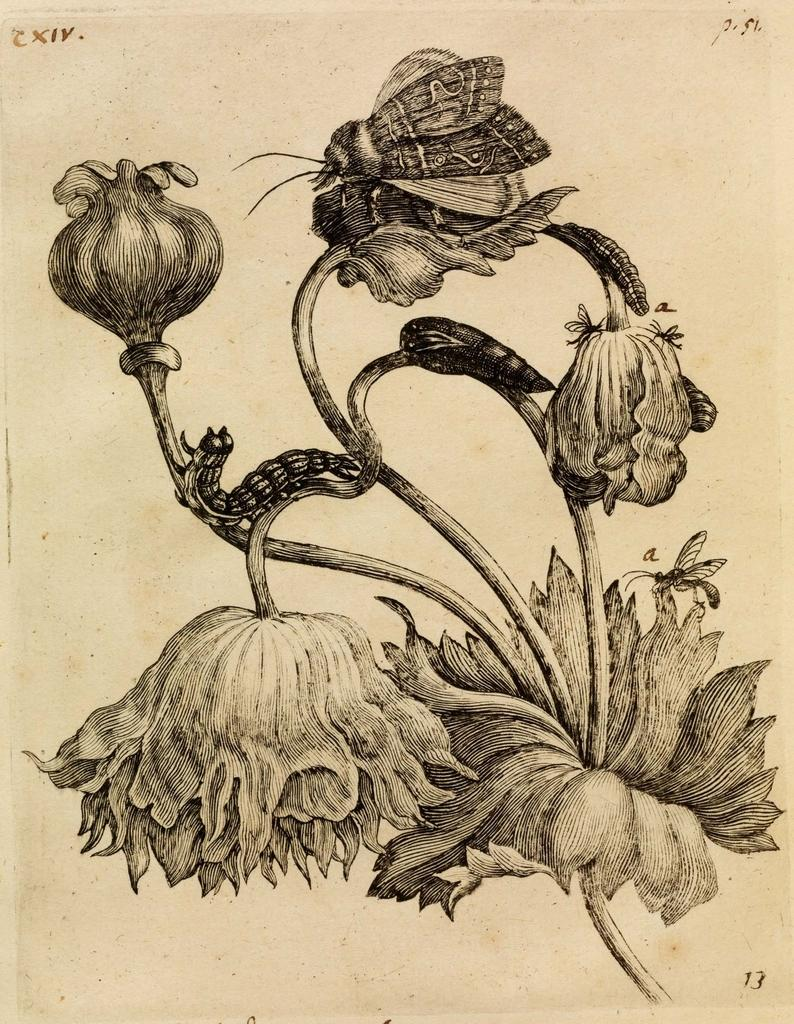What type of image is shown in the picture? The image contains a black and white picture. What is the main subject of the black and white picture? The picture depicts a plant. Are there any other elements present in the picture besides the plant? Yes, there are insects present on the plant. What type of roof can be seen on the arch in the image? There is no roof or arch present in the image; it features a black and white picture of a plant with insects on it. 